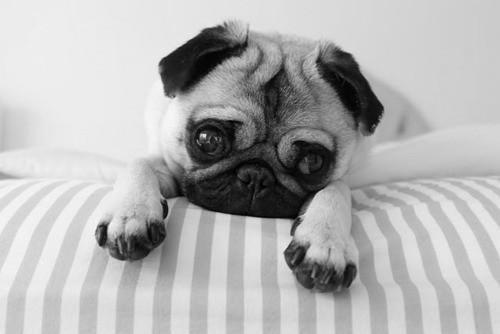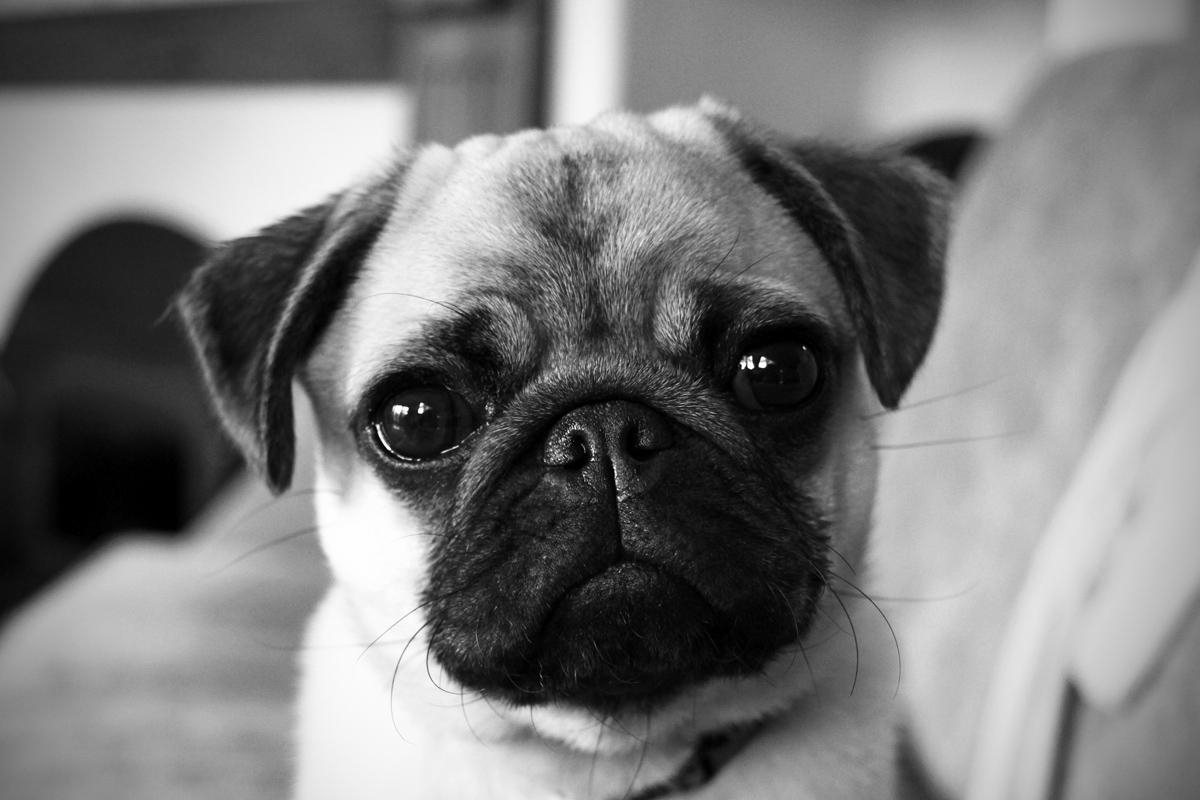The first image is the image on the left, the second image is the image on the right. Given the left and right images, does the statement "There is exactly one light colored dog with a dark muzzle in each image." hold true? Answer yes or no. Yes. The first image is the image on the left, the second image is the image on the right. Considering the images on both sides, is "Each image contains multiple pugs, and each image includes at least one black pug." valid? Answer yes or no. No. 